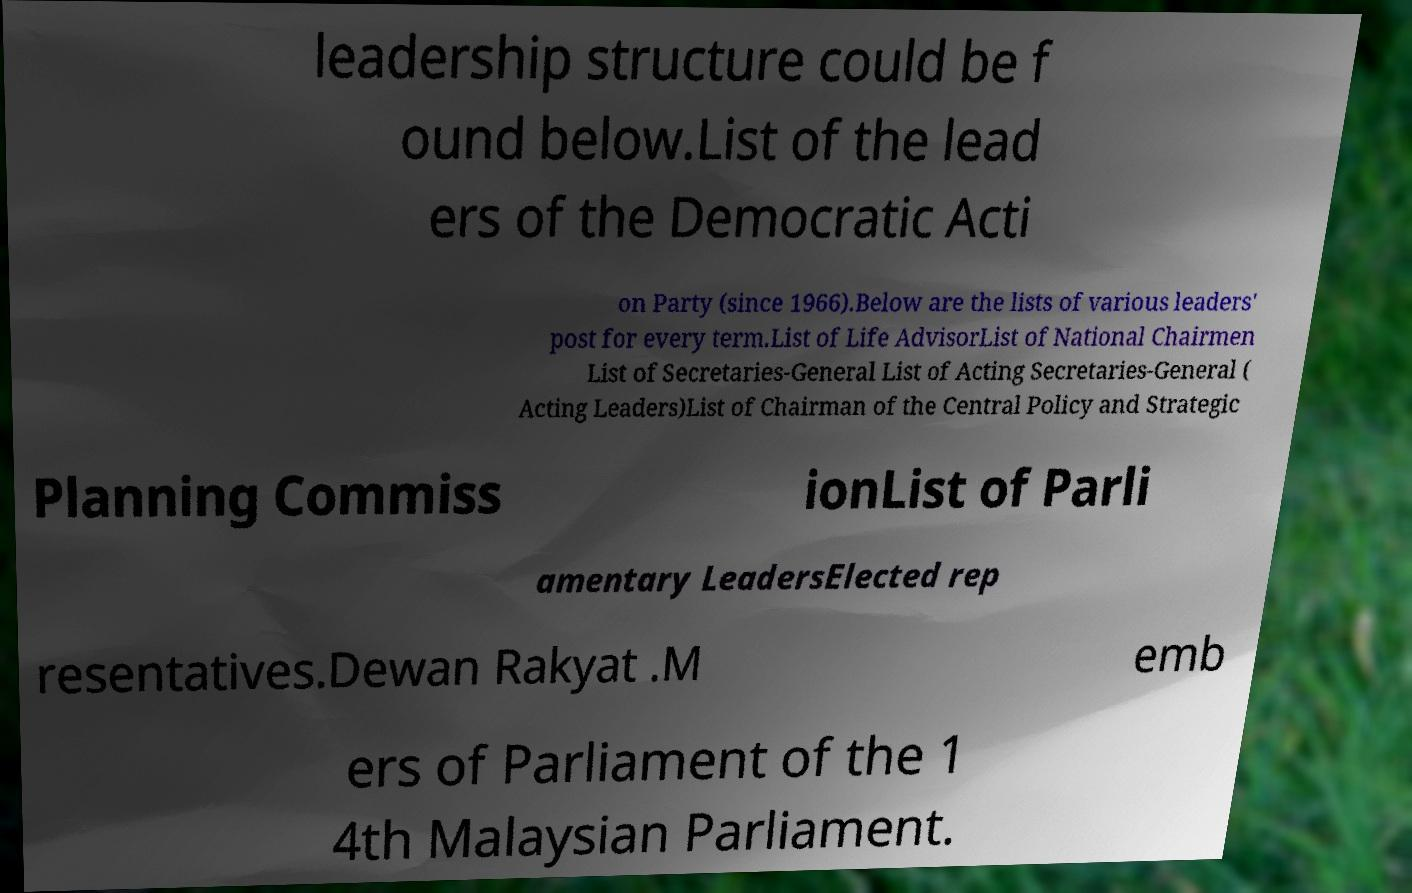What messages or text are displayed in this image? I need them in a readable, typed format. leadership structure could be f ound below.List of the lead ers of the Democratic Acti on Party (since 1966).Below are the lists of various leaders' post for every term.List of Life AdvisorList of National Chairmen List of Secretaries-General List of Acting Secretaries-General ( Acting Leaders)List of Chairman of the Central Policy and Strategic Planning Commiss ionList of Parli amentary LeadersElected rep resentatives.Dewan Rakyat .M emb ers of Parliament of the 1 4th Malaysian Parliament. 